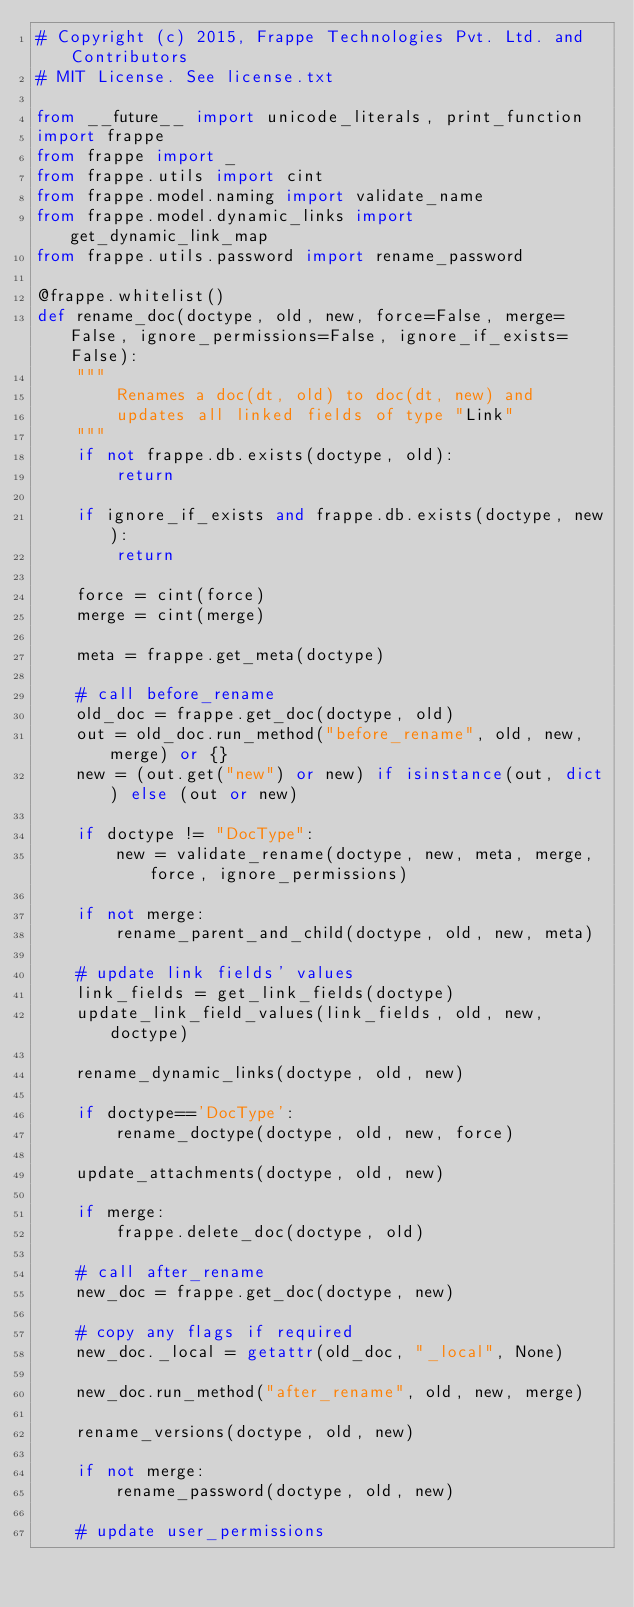<code> <loc_0><loc_0><loc_500><loc_500><_Python_># Copyright (c) 2015, Frappe Technologies Pvt. Ltd. and Contributors
# MIT License. See license.txt

from __future__ import unicode_literals, print_function
import frappe
from frappe import _
from frappe.utils import cint
from frappe.model.naming import validate_name
from frappe.model.dynamic_links import get_dynamic_link_map
from frappe.utils.password import rename_password

@frappe.whitelist()
def rename_doc(doctype, old, new, force=False, merge=False, ignore_permissions=False, ignore_if_exists=False):
	"""
		Renames a doc(dt, old) to doc(dt, new) and
		updates all linked fields of type "Link"
	"""
	if not frappe.db.exists(doctype, old):
		return

	if ignore_if_exists and frappe.db.exists(doctype, new):
		return

	force = cint(force)
	merge = cint(merge)

	meta = frappe.get_meta(doctype)

	# call before_rename
	old_doc = frappe.get_doc(doctype, old)
	out = old_doc.run_method("before_rename", old, new, merge) or {}
	new = (out.get("new") or new) if isinstance(out, dict) else (out or new)

	if doctype != "DocType":
		new = validate_rename(doctype, new, meta, merge, force, ignore_permissions)

	if not merge:
		rename_parent_and_child(doctype, old, new, meta)

	# update link fields' values
	link_fields = get_link_fields(doctype)
	update_link_field_values(link_fields, old, new, doctype)

	rename_dynamic_links(doctype, old, new)

	if doctype=='DocType':
		rename_doctype(doctype, old, new, force)

	update_attachments(doctype, old, new)

	if merge:
		frappe.delete_doc(doctype, old)

	# call after_rename
	new_doc = frappe.get_doc(doctype, new)

	# copy any flags if required
	new_doc._local = getattr(old_doc, "_local", None)

	new_doc.run_method("after_rename", old, new, merge)

	rename_versions(doctype, old, new)

	if not merge:
		rename_password(doctype, old, new)

	# update user_permissions</code> 